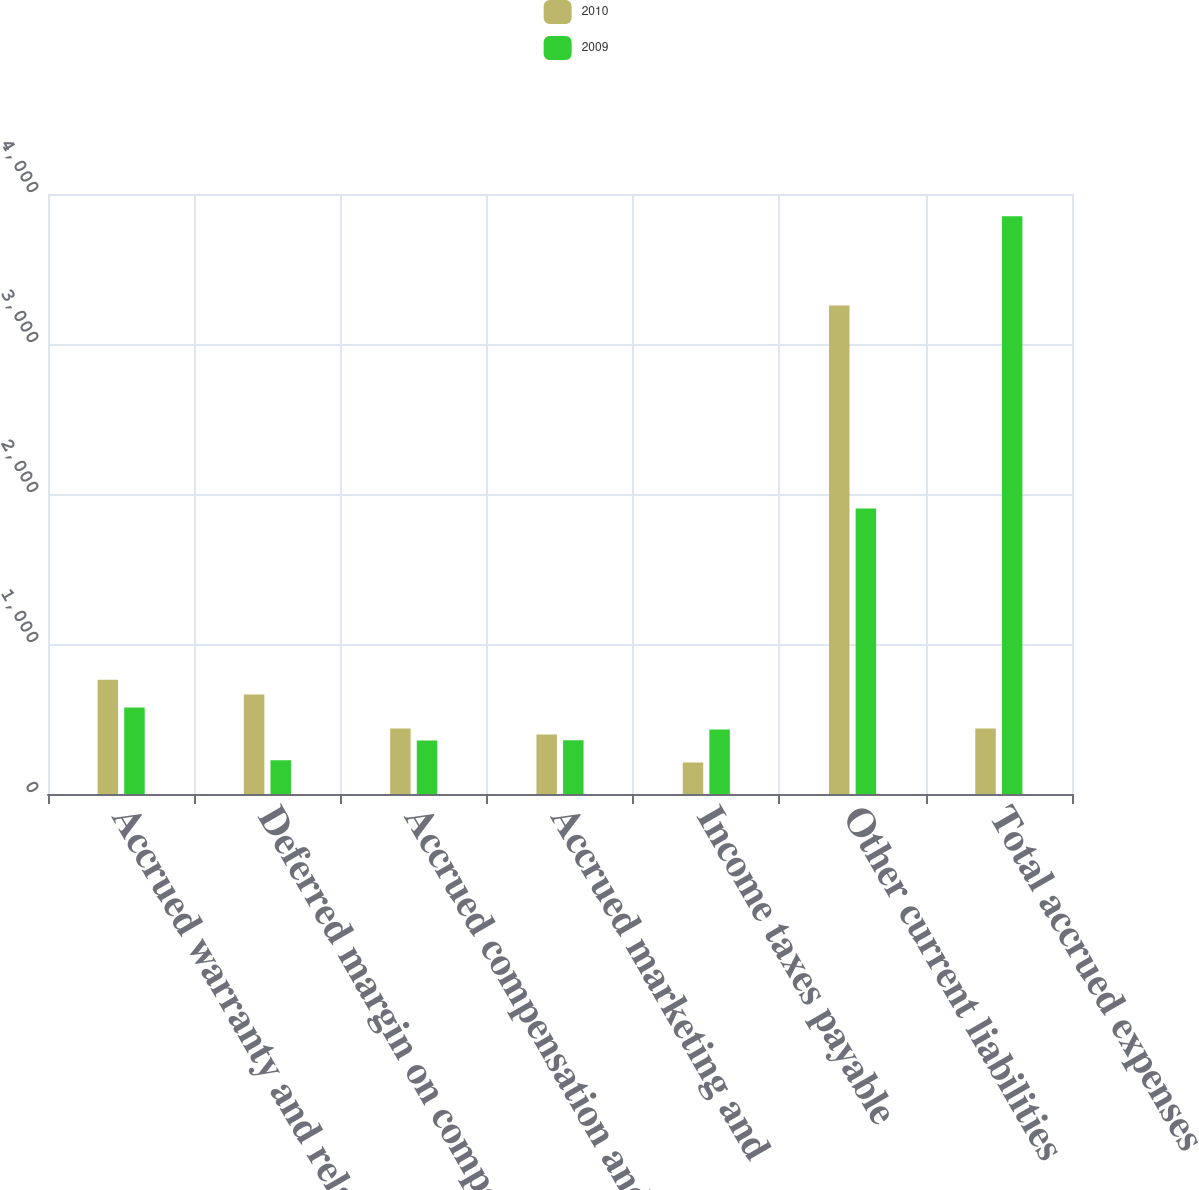Convert chart. <chart><loc_0><loc_0><loc_500><loc_500><stacked_bar_chart><ecel><fcel>Accrued warranty and related<fcel>Deferred margin on component<fcel>Accrued compensation and<fcel>Accrued marketing and<fcel>Income taxes payable<fcel>Other current liabilities<fcel>Total accrued expenses<nl><fcel>2010<fcel>761<fcel>663<fcel>436<fcel>396<fcel>210<fcel>3257<fcel>436<nl><fcel>2009<fcel>577<fcel>225<fcel>357<fcel>359<fcel>430<fcel>1904<fcel>3852<nl></chart> 